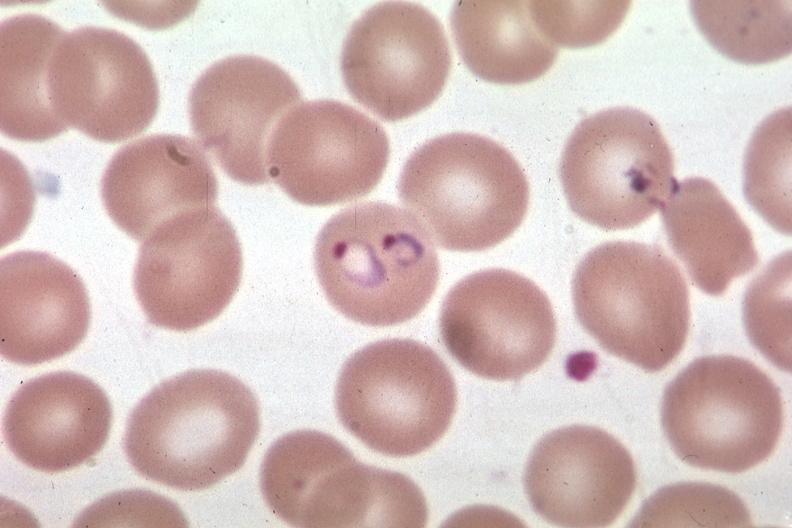does this image show oil wrights excellent?
Answer the question using a single word or phrase. Yes 